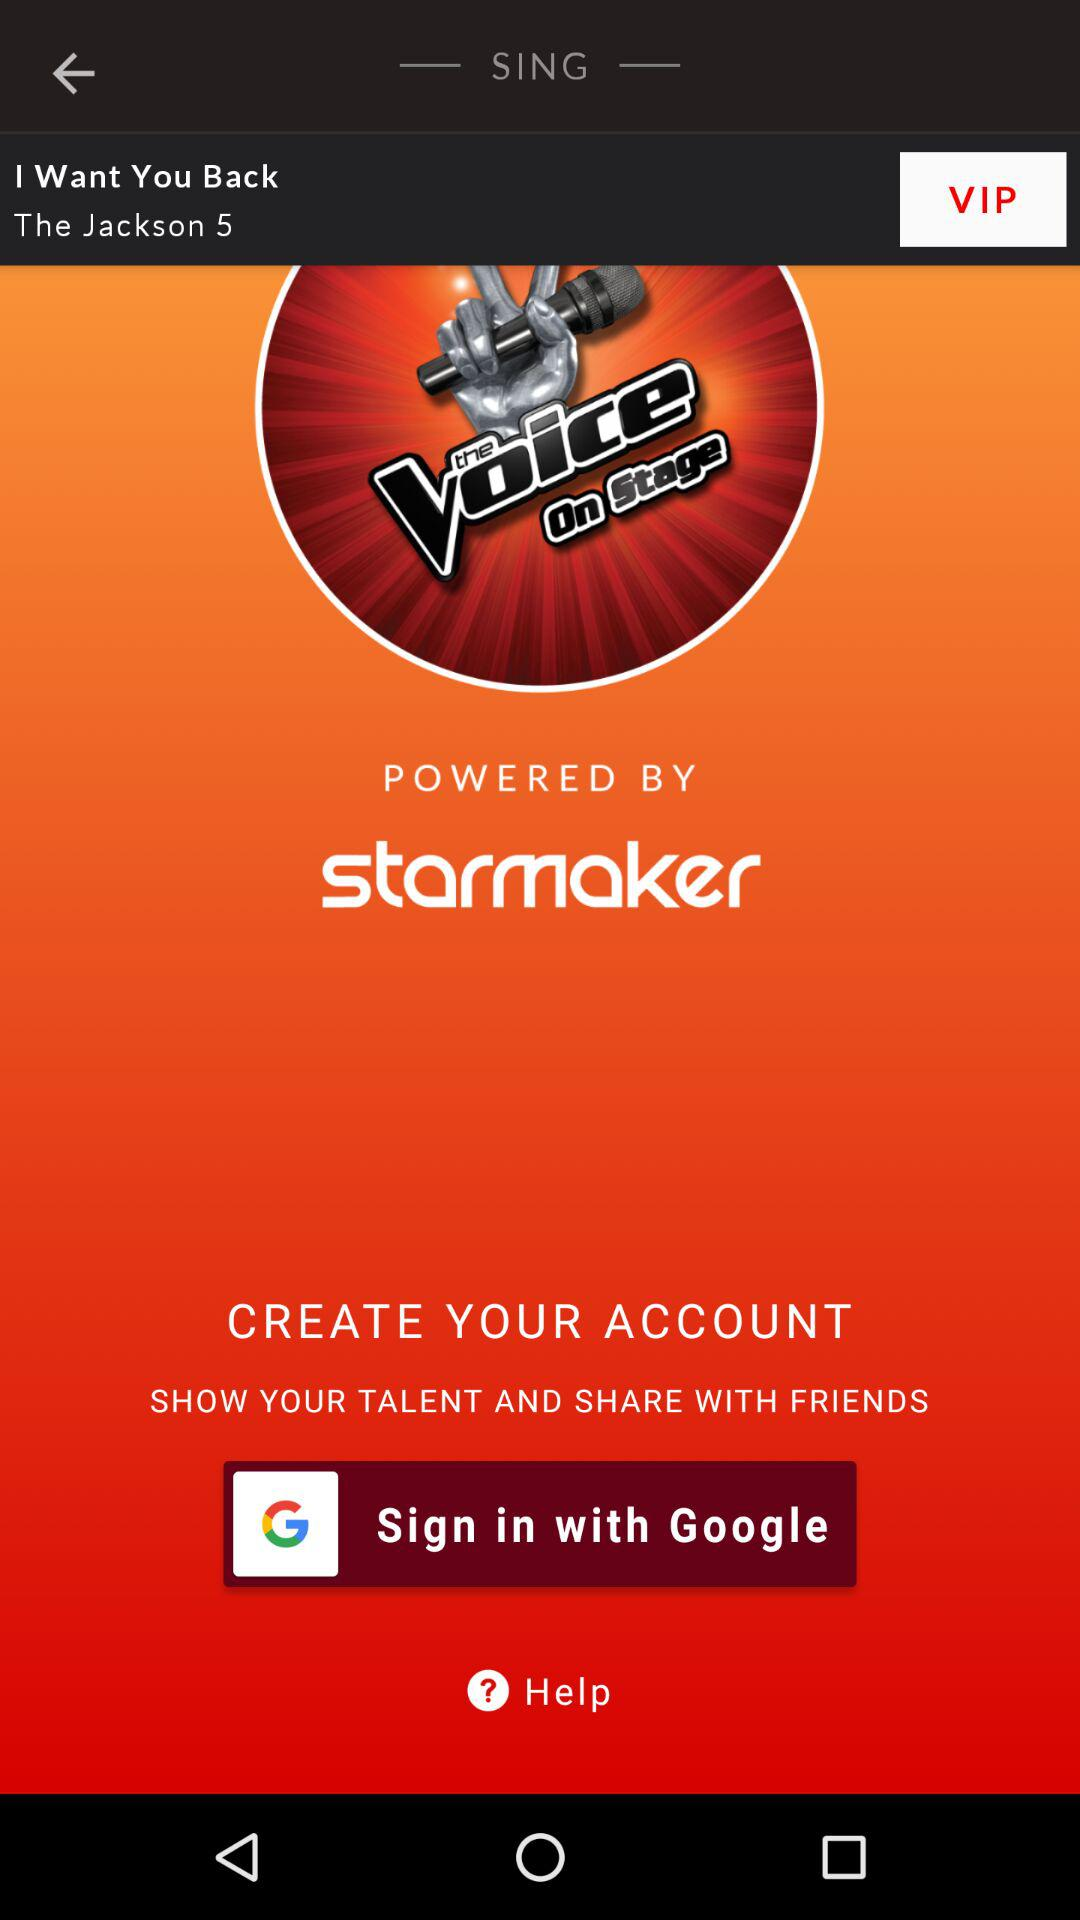What is the name of the application? The name of the application is "the Voice On Stage". 